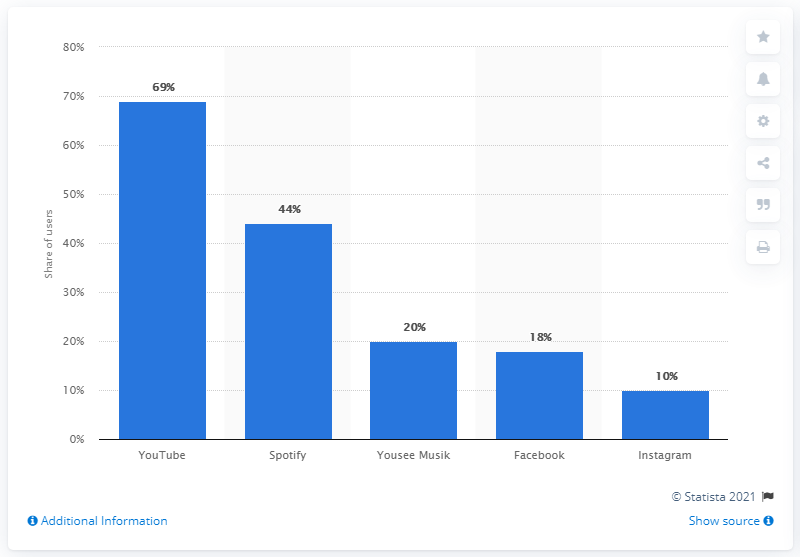What is the share difference between the top two services? The bar chart reveals that YouTube leads with 69% while Spotify has 44%. The share difference between YouTube and Spotify is therefore 25 percentage points. 